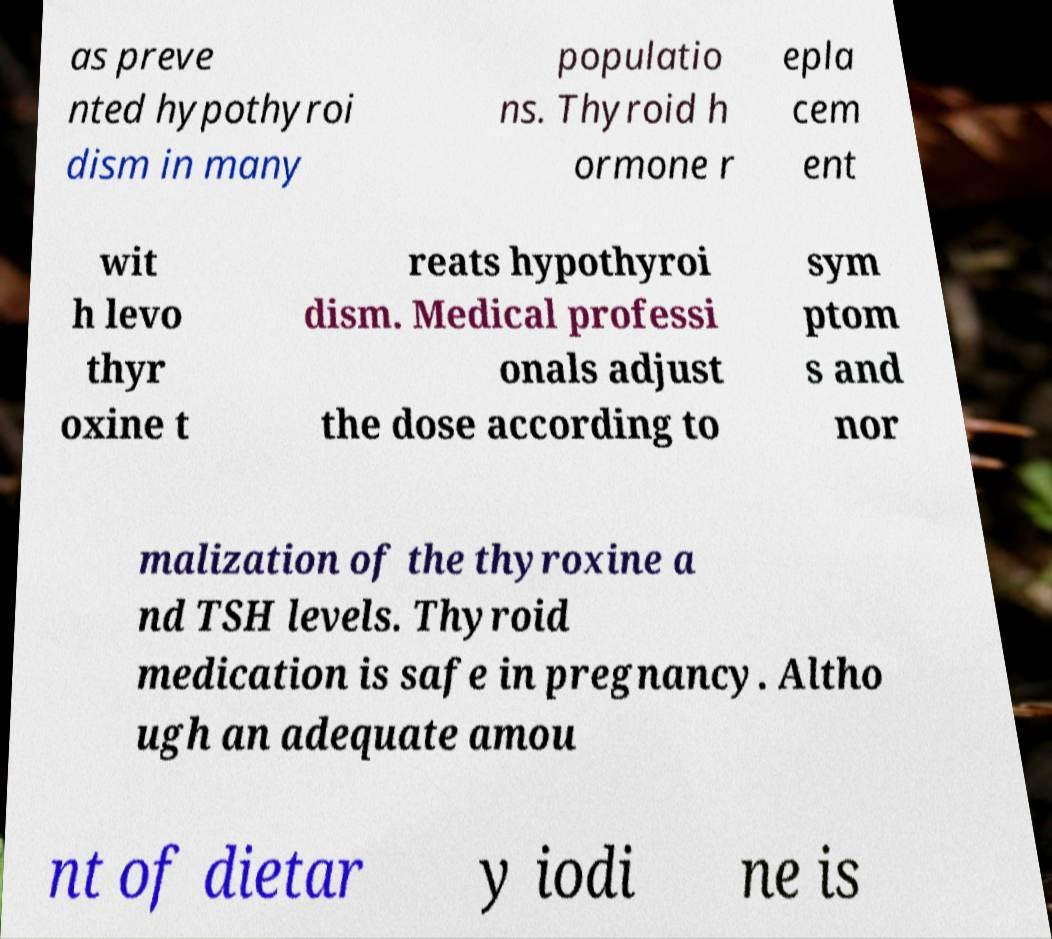I need the written content from this picture converted into text. Can you do that? as preve nted hypothyroi dism in many populatio ns. Thyroid h ormone r epla cem ent wit h levo thyr oxine t reats hypothyroi dism. Medical professi onals adjust the dose according to sym ptom s and nor malization of the thyroxine a nd TSH levels. Thyroid medication is safe in pregnancy. Altho ugh an adequate amou nt of dietar y iodi ne is 